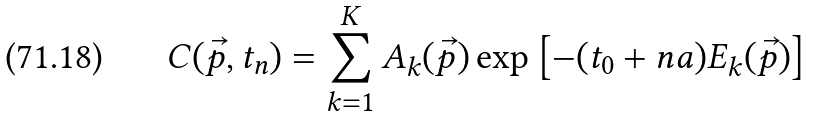<formula> <loc_0><loc_0><loc_500><loc_500>C ( \vec { p } , t _ { n } ) = \sum _ { k = 1 } ^ { K } A _ { k } ( \vec { p } ) \exp \left [ - ( t _ { 0 } + n a ) E _ { k } ( \vec { p } ) \right ]</formula> 